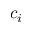<formula> <loc_0><loc_0><loc_500><loc_500>c _ { i }</formula> 